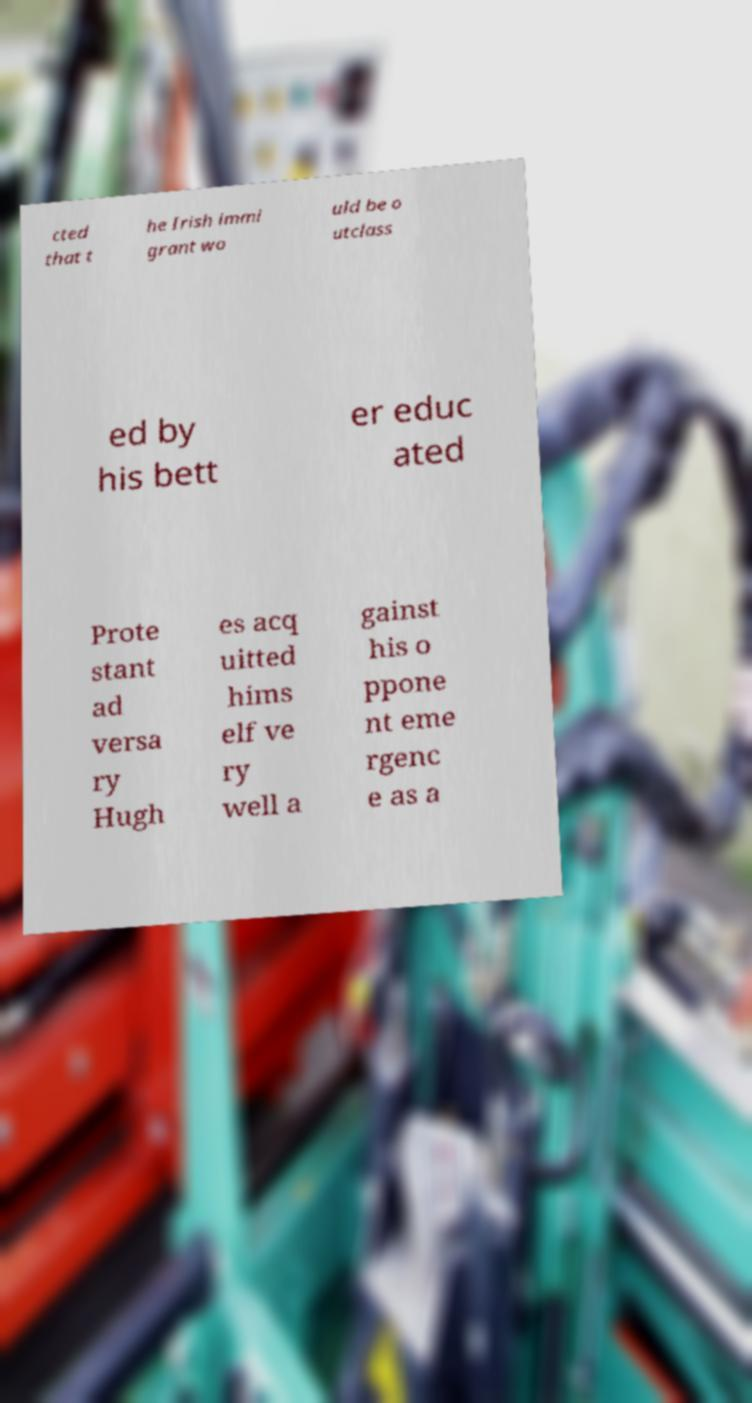Can you read and provide the text displayed in the image?This photo seems to have some interesting text. Can you extract and type it out for me? cted that t he Irish immi grant wo uld be o utclass ed by his bett er educ ated Prote stant ad versa ry Hugh es acq uitted hims elf ve ry well a gainst his o ppone nt eme rgenc e as a 